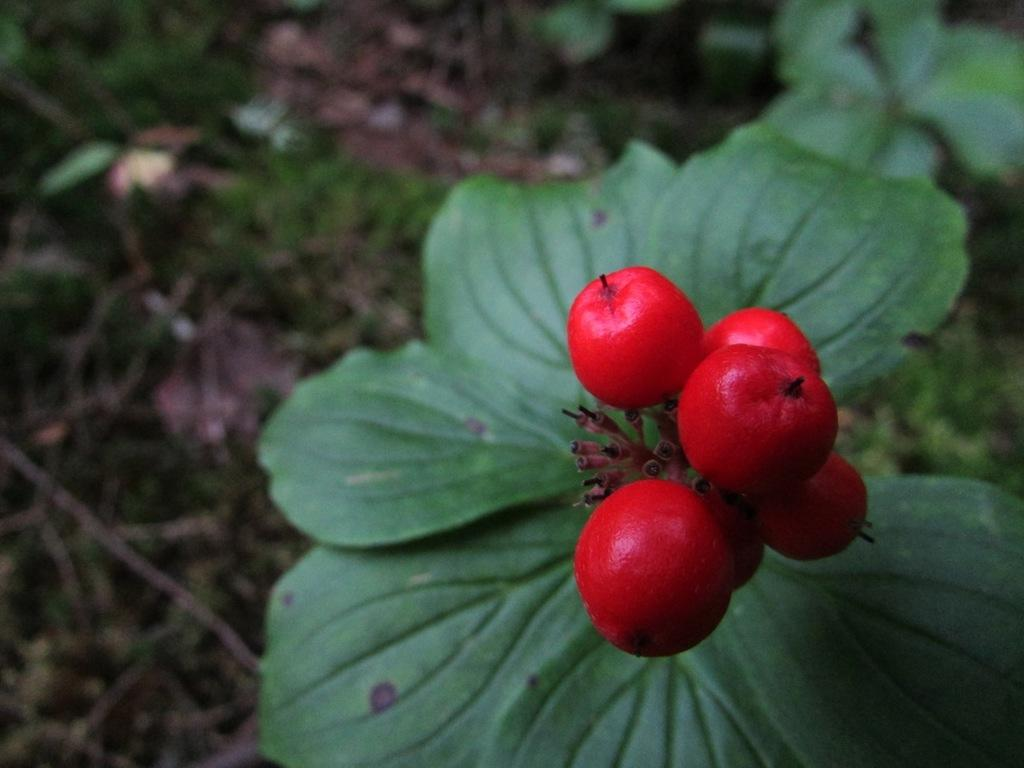What is located in the middle of the image? There are fruits in the middle of the image. What can be seen behind the fruits? There are plants behind the fruits. How would you describe the background of the image? The background of the image is blurred. What type of pet can be seen sneezing on the calendar in the image? There is no pet, sneeze, or calendar present in the image. 